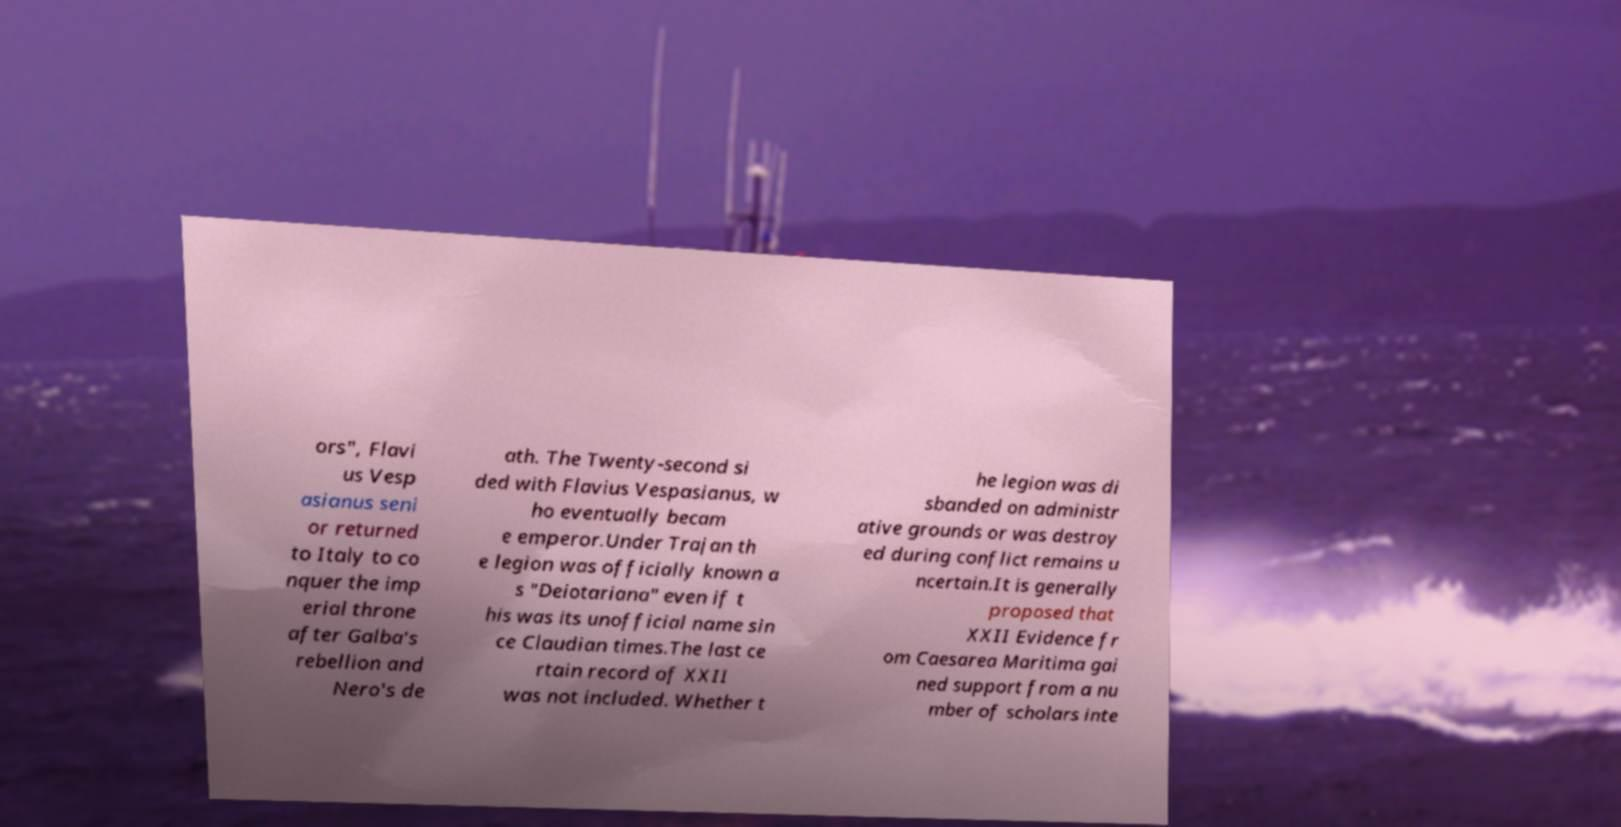Please read and relay the text visible in this image. What does it say? ors", Flavi us Vesp asianus seni or returned to Italy to co nquer the imp erial throne after Galba's rebellion and Nero's de ath. The Twenty-second si ded with Flavius Vespasianus, w ho eventually becam e emperor.Under Trajan th e legion was officially known a s "Deiotariana" even if t his was its unofficial name sin ce Claudian times.The last ce rtain record of XXII was not included. Whether t he legion was di sbanded on administr ative grounds or was destroy ed during conflict remains u ncertain.It is generally proposed that XXII Evidence fr om Caesarea Maritima gai ned support from a nu mber of scholars inte 